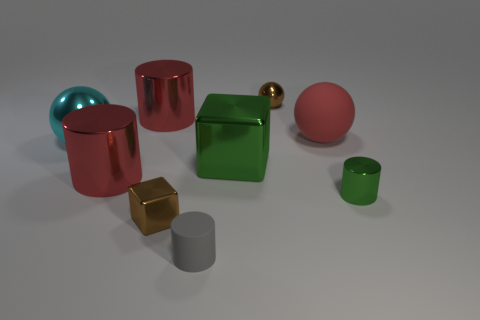Subtract all green cylinders. How many cylinders are left? 3 Subtract all tiny shiny cylinders. How many cylinders are left? 3 Add 1 large green spheres. How many objects exist? 10 Subtract all yellow cylinders. Subtract all cyan spheres. How many cylinders are left? 4 Subtract all blocks. How many objects are left? 7 Add 8 large green shiny objects. How many large green shiny objects exist? 9 Subtract 0 blue cubes. How many objects are left? 9 Subtract all tiny things. Subtract all tiny metal cubes. How many objects are left? 4 Add 7 brown spheres. How many brown spheres are left? 8 